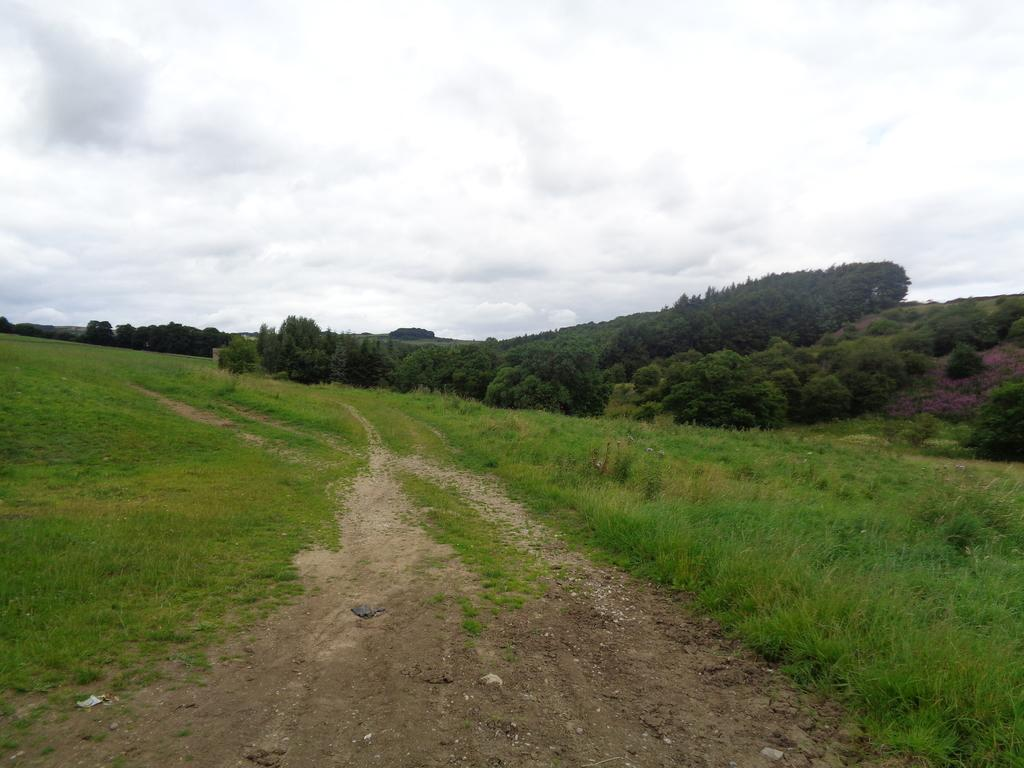What type of vegetation can be seen in the image? There is grass in the image. Are there any other plants visible in the image? Yes, there are trees in the image. What kind of surface can be seen in the image? There is a path in the image. What is visible in the background of the image? The sky is visible in the background of the image. What can be observed in the sky? Clouds are present in the sky. What type of clam can be seen in the image? There are no clams present in the image; it features grass, trees, a path, and a sky with clouds. Is the image set during winter? The image does not provide any specific information about the season, so it cannot be determined if it is set during winter. 